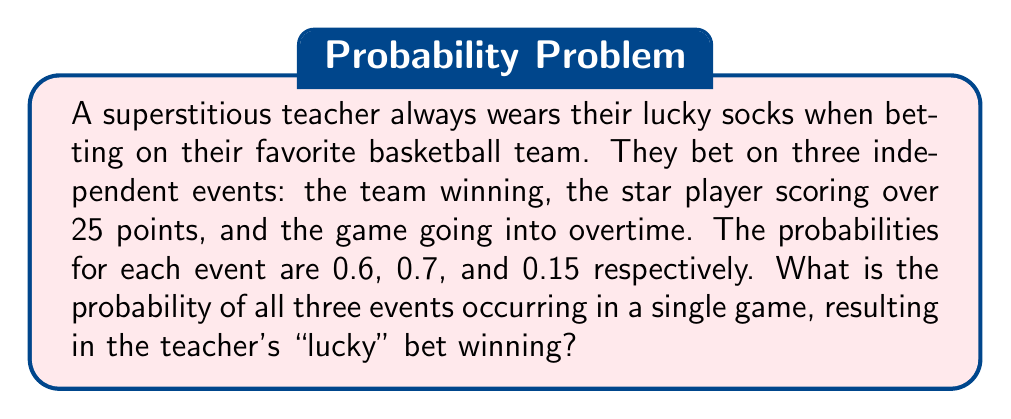Help me with this question. To solve this problem, we need to use the multiplication rule for independent events. Since all three events must occur for the bet to win, we multiply the individual probabilities:

1. Probability of the team winning: $P(W) = 0.6$
2. Probability of the star player scoring over 25 points: $P(S) = 0.7$
3. Probability of the game going into overtime: $P(O) = 0.15$

The probability of all three events occurring together is:

$$P(\text{all events}) = P(W) \times P(S) \times P(O)$$

Substituting the values:

$$P(\text{all events}) = 0.6 \times 0.7 \times 0.15$$

Calculating:

$$P(\text{all events}) = 0.063$$

Therefore, the probability of the teacher's "lucky" bet winning is 0.063 or 6.3%.
Answer: $0.063$ 